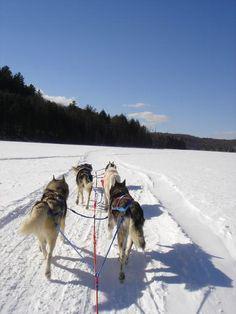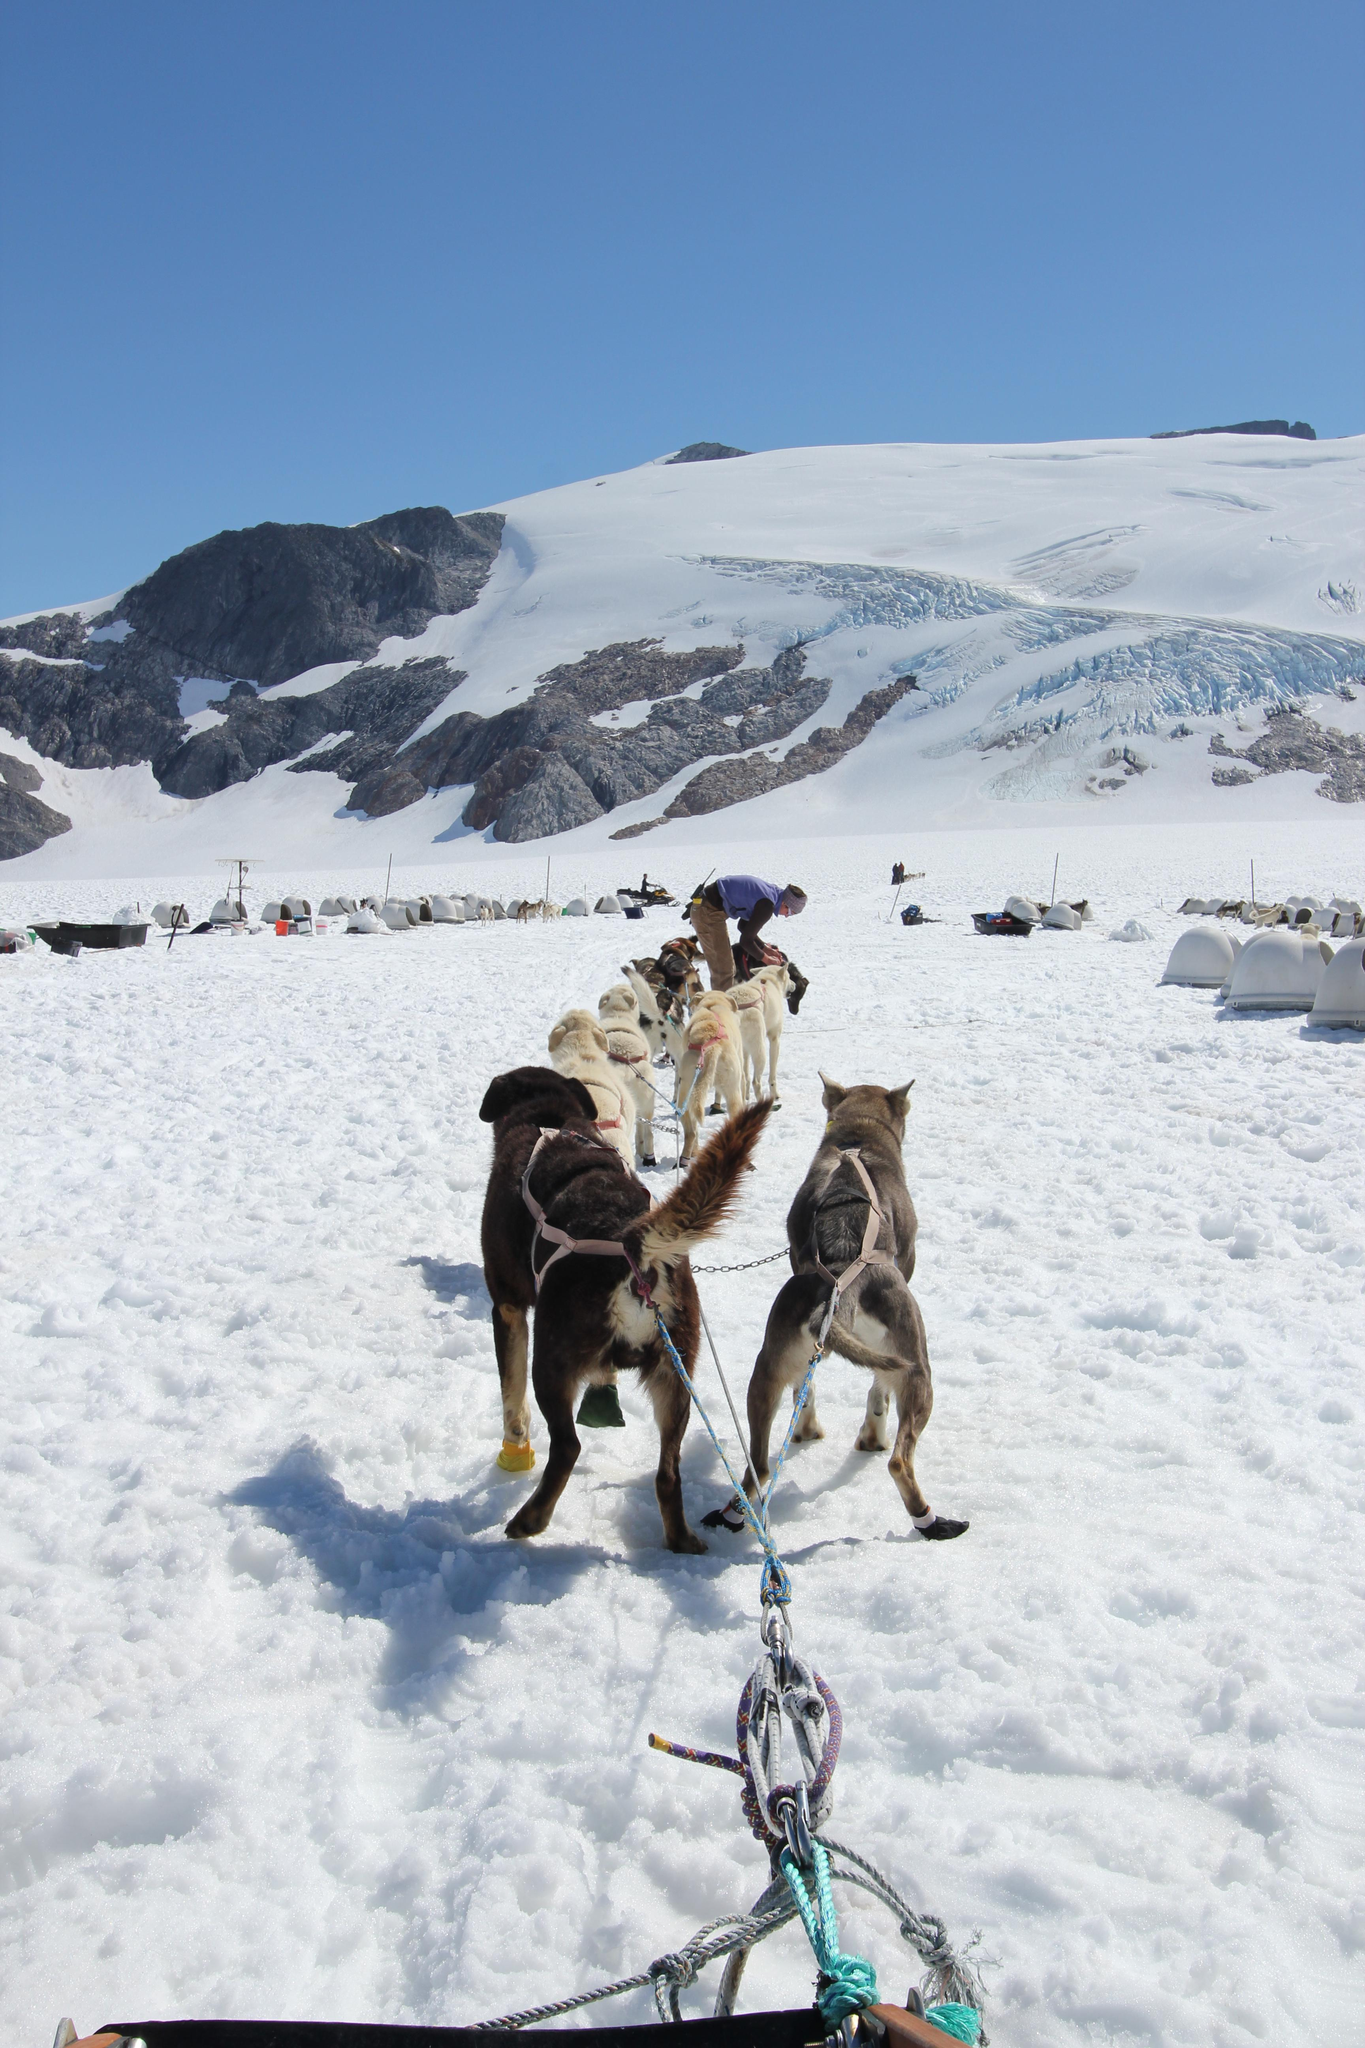The first image is the image on the left, the second image is the image on the right. For the images displayed, is the sentence "The sled is red in the image on the left" factually correct? Answer yes or no. No. The first image is the image on the left, the second image is the image on the right. Evaluate the accuracy of this statement regarding the images: "There is at least one human pictured.". Is it true? Answer yes or no. No. 